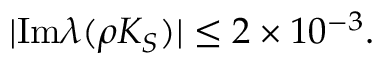Convert formula to latex. <formula><loc_0><loc_0><loc_500><loc_500>| I m \lambda ( \rho K _ { S } ) | \leq 2 \times 1 0 ^ { - 3 } .</formula> 